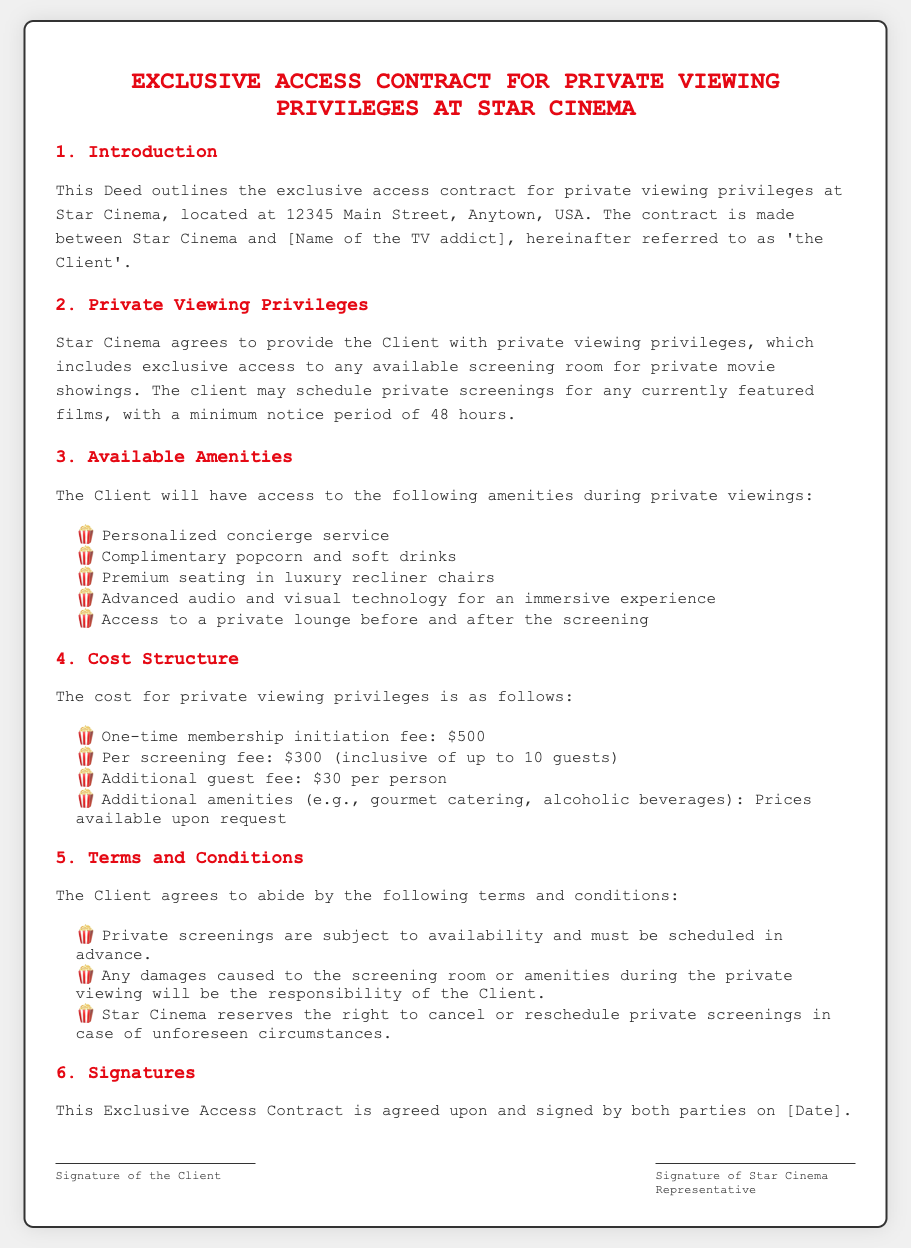What is the contract title? The contract title is specifically outlined at the top of the document.
Answer: Exclusive Access Contract for Private Viewing Privileges at Star Cinema Where is Star Cinema located? The location of Star Cinema is stated in the introduction section of the document.
Answer: 12345 Main Street, Anytown, USA What is the minimum notice period for scheduling private screenings? The minimum notice period is mentioned in the section regarding private viewing privileges.
Answer: 48 hours How much is the one-time membership initiation fee? The cost structure section details the fees associated with the contract.
Answer: $500 What amenities are included during private viewings? The available amenities are explicitly listed in the amenities section of the document.
Answer: Personalized concierge service, complimentary popcorn and soft drinks, premium seating in luxury recliner chairs, advanced audio and visual technology for an immersive experience, access to a private lounge before and after the screening What is the additional guest fee? The cost structure section specifies the fee for additional guests beyond the initial number included.
Answer: $30 per person What is required of the Client regarding damages? The terms and conditions section outlines the Client's responsibility in case of damages.
Answer: Responsibility for damages Who needs to sign the contract? The signature section indicates the parties involved who need to endorse the agreement.
Answer: Client and Star Cinema Representative How is the private viewings scheduling described? The terms regarding the scheduling of private screenings are elaborated upon in the contract.
Answer: Subject to availability and must be scheduled in advance 